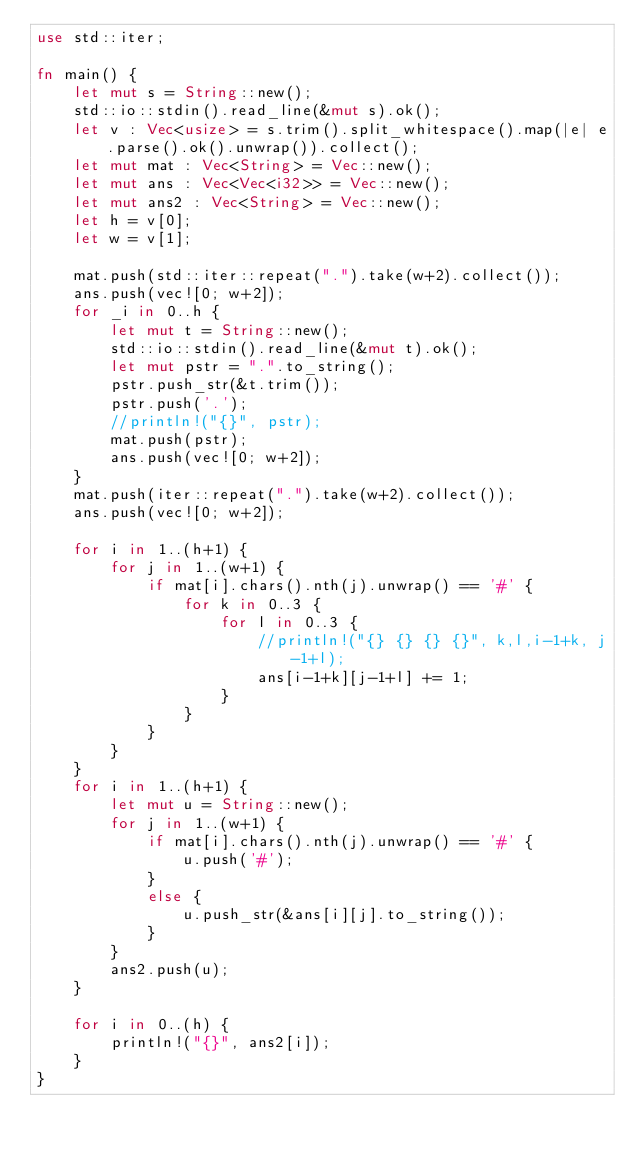<code> <loc_0><loc_0><loc_500><loc_500><_Rust_>use std::iter;

fn main() {
    let mut s = String::new();
    std::io::stdin().read_line(&mut s).ok();
    let v : Vec<usize> = s.trim().split_whitespace().map(|e| e.parse().ok().unwrap()).collect();
    let mut mat : Vec<String> = Vec::new();
    let mut ans : Vec<Vec<i32>> = Vec::new();
    let mut ans2 : Vec<String> = Vec::new();
    let h = v[0];
    let w = v[1];

    mat.push(std::iter::repeat(".").take(w+2).collect());
    ans.push(vec![0; w+2]);
    for _i in 0..h {
        let mut t = String::new();
        std::io::stdin().read_line(&mut t).ok();
        let mut pstr = ".".to_string();
        pstr.push_str(&t.trim());
        pstr.push('.');
        //println!("{}", pstr);
        mat.push(pstr);
        ans.push(vec![0; w+2]);
    }
    mat.push(iter::repeat(".").take(w+2).collect());
    ans.push(vec![0; w+2]);

    for i in 1..(h+1) {
        for j in 1..(w+1) {
            if mat[i].chars().nth(j).unwrap() == '#' {
                for k in 0..3 {
                    for l in 0..3 {
                        //println!("{} {} {} {}", k,l,i-1+k, j-1+l);
                        ans[i-1+k][j-1+l] += 1;
                    }
                }
            }
        }
    }
    for i in 1..(h+1) {
        let mut u = String::new();
        for j in 1..(w+1) {
            if mat[i].chars().nth(j).unwrap() == '#' {
                u.push('#');
            }
            else {
                u.push_str(&ans[i][j].to_string());
            }
        }
        ans2.push(u);
    }

    for i in 0..(h) {
        println!("{}", ans2[i]);
    }
}
</code> 